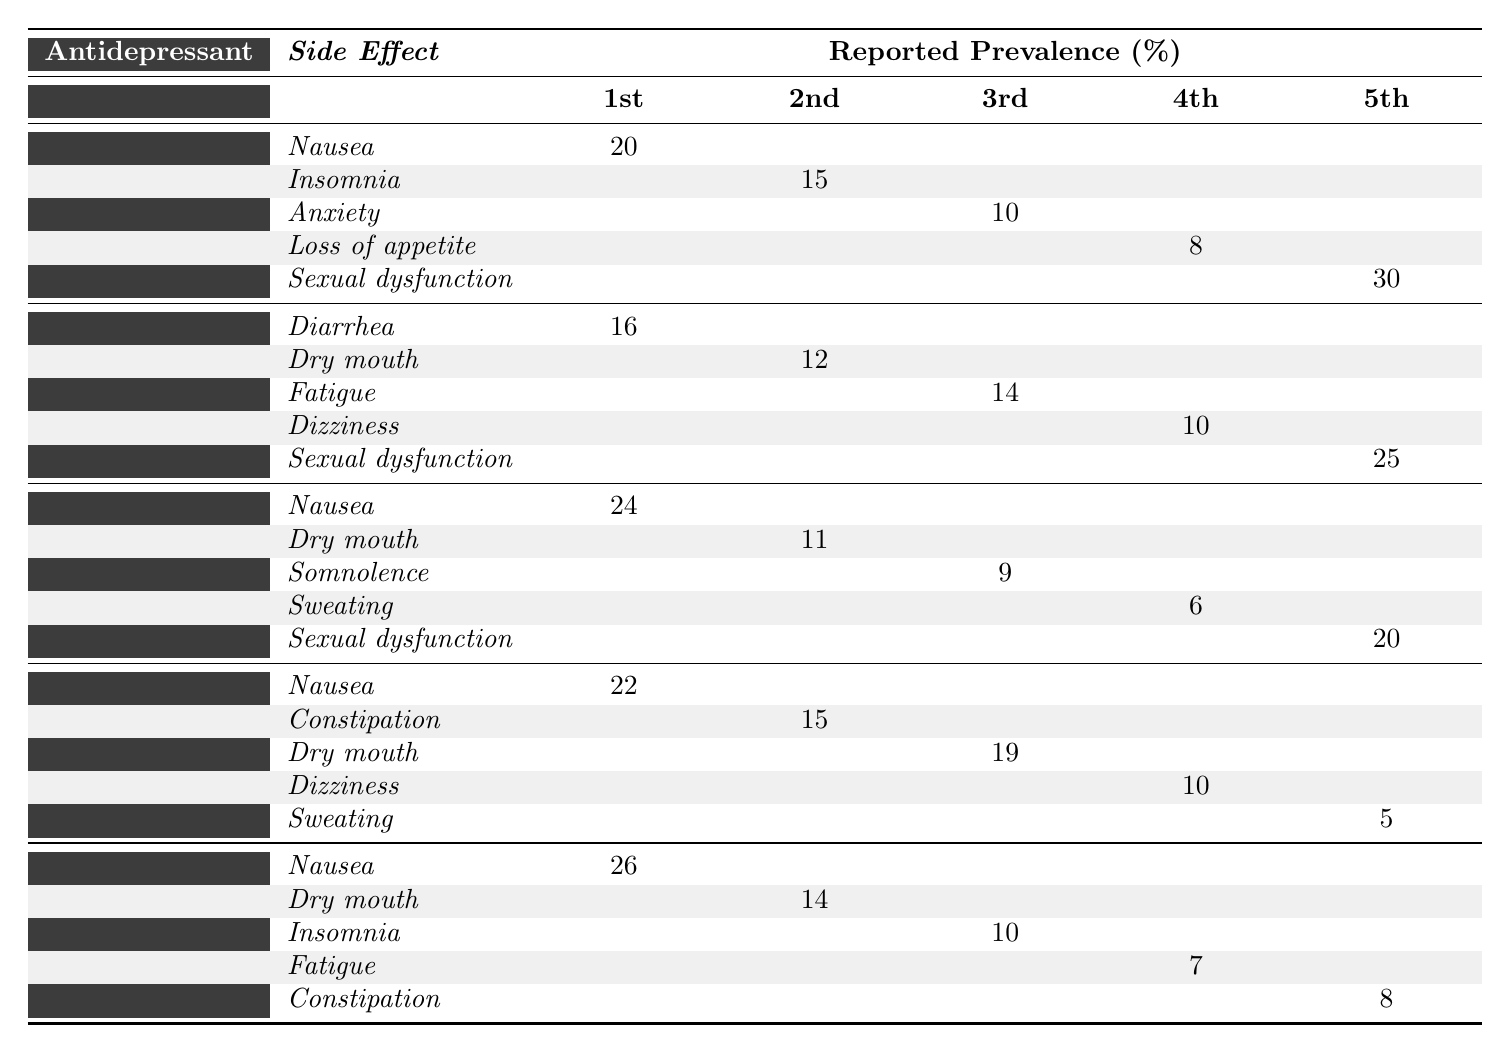What is the most common side effect reported for Fluoxetine? The table shows that the most common side effect for Fluoxetine is "Sexual dysfunction," which has a reported prevalence of 30%.
Answer: Sexual dysfunction Which antidepressant has the highest reported prevalence of Nausea? The reported prevalence of Nausea for each antidepressant shows that Duloxetine has the highest prevalence at 26%.
Answer: Duloxetine Is Sexual dysfunction a side effect reported for all antidepressants listed in the table? By examining the table, Sexual dysfunction is reported as a side effect for all antidepressants: Fluoxetine, Sertraline, Citalopram, Venlafaxine, and Duloxetine.
Answer: Yes What is the average reported prevalence of Sexual dysfunction across all antidepressants? The reported prevalences of Sexual dysfunction are: 30% (Fluoxetine), 25% (Sertraline), 20% (Citalopram), 20% (Venlafaxine), and 30% (Duloxetine). The average is (30 + 25 + 20 + 20 + 30) / 5 = 25%.
Answer: 25% Which antidepressant has the lowest reported prevalence of Insomnia? The table indicates that Duloxetine has the lowest reported prevalence of Insomnia at 10%.
Answer: Duloxetine How much higher is the prevalence of Nausea in Citalopram compared to Venlafaxine? The reported prevalence of Nausea for Citalopram is 24%, while for Venlafaxine, it is 22%. The difference is calculated as 24% - 22% = 2%.
Answer: 2% Which side effect is reported as the second highest for Sertraline? Looking at the table, the second highest side effect for Sertraline is "Fatigue," with a reported prevalence of 14%.
Answer: Fatigue What side effect has the lowest reported prevalence among the antidepressants? By reviewing the table, the lowest reported prevalence is for "Sweating" in Venlafaxine at 5%.
Answer: Sweating Is the prevalence of Dry mouth higher in Duloxetine compared to Sertraline? The reported prevalence for Dry mouth is 14% in Duloxetine and 12% in Sertraline; therefore, Duloxetine has a higher prevalence.
Answer: Yes What is the total reported prevalence of the common side effects for Venlafaxine? The reported prevalences for Venlafaxine are: Nausea (22%), Constipation (15%), Dry mouth (19%), Dizziness (10%), and Sweating (5%). The total is 22 + 15 + 19 + 10 + 5 = 71%.
Answer: 71% 